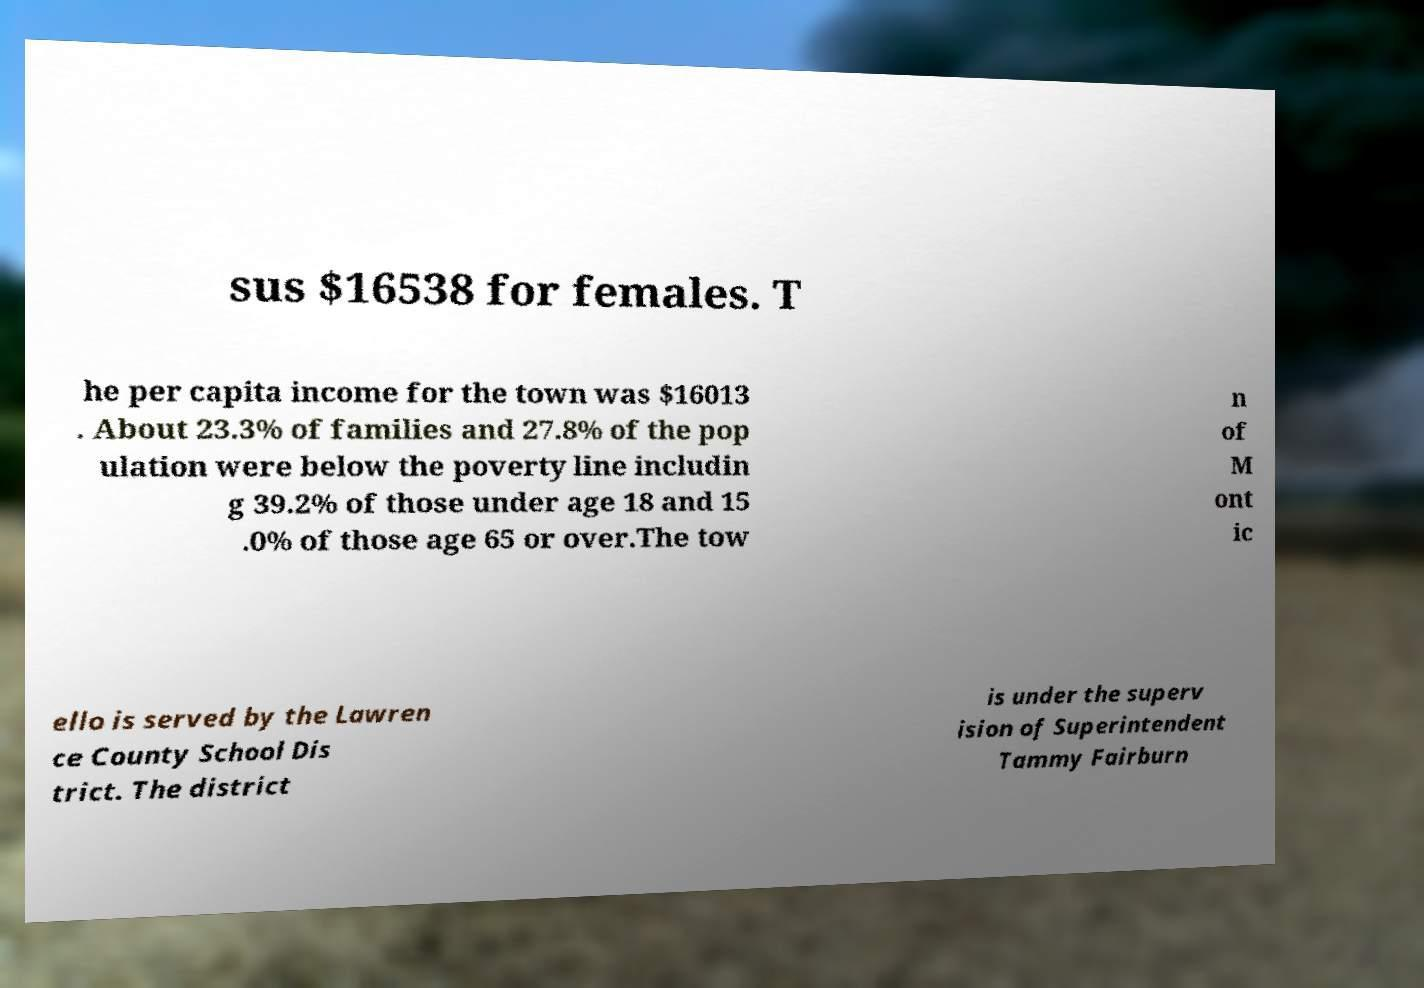Could you assist in decoding the text presented in this image and type it out clearly? sus $16538 for females. T he per capita income for the town was $16013 . About 23.3% of families and 27.8% of the pop ulation were below the poverty line includin g 39.2% of those under age 18 and 15 .0% of those age 65 or over.The tow n of M ont ic ello is served by the Lawren ce County School Dis trict. The district is under the superv ision of Superintendent Tammy Fairburn 